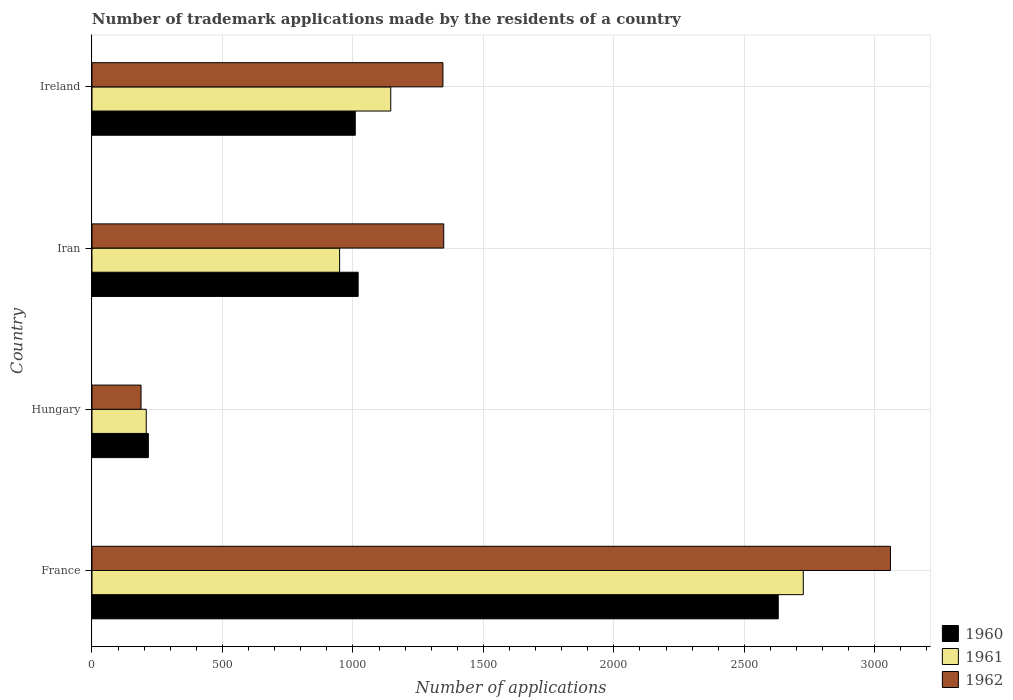Are the number of bars on each tick of the Y-axis equal?
Your answer should be very brief. Yes. How many bars are there on the 4th tick from the top?
Your response must be concise. 3. What is the label of the 3rd group of bars from the top?
Your answer should be compact. Hungary. What is the number of trademark applications made by the residents in 1962 in Iran?
Your answer should be very brief. 1348. Across all countries, what is the maximum number of trademark applications made by the residents in 1960?
Provide a short and direct response. 2630. Across all countries, what is the minimum number of trademark applications made by the residents in 1961?
Your response must be concise. 208. In which country was the number of trademark applications made by the residents in 1961 minimum?
Your response must be concise. Hungary. What is the total number of trademark applications made by the residents in 1961 in the graph?
Provide a short and direct response. 5028. What is the difference between the number of trademark applications made by the residents in 1961 in France and that in Hungary?
Offer a terse response. 2518. What is the difference between the number of trademark applications made by the residents in 1960 in Ireland and the number of trademark applications made by the residents in 1961 in France?
Provide a short and direct response. -1717. What is the average number of trademark applications made by the residents in 1962 per country?
Provide a short and direct response. 1485.25. What is the difference between the number of trademark applications made by the residents in 1960 and number of trademark applications made by the residents in 1961 in Ireland?
Your answer should be compact. -136. What is the ratio of the number of trademark applications made by the residents in 1960 in France to that in Iran?
Your answer should be compact. 2.58. Is the difference between the number of trademark applications made by the residents in 1960 in France and Hungary greater than the difference between the number of trademark applications made by the residents in 1961 in France and Hungary?
Keep it short and to the point. No. What is the difference between the highest and the second highest number of trademark applications made by the residents in 1960?
Keep it short and to the point. 1610. What is the difference between the highest and the lowest number of trademark applications made by the residents in 1962?
Give a very brief answer. 2872. Is the sum of the number of trademark applications made by the residents in 1962 in Iran and Ireland greater than the maximum number of trademark applications made by the residents in 1960 across all countries?
Your answer should be compact. Yes. Is it the case that in every country, the sum of the number of trademark applications made by the residents in 1961 and number of trademark applications made by the residents in 1962 is greater than the number of trademark applications made by the residents in 1960?
Offer a very short reply. Yes. Are all the bars in the graph horizontal?
Provide a succinct answer. Yes. What is the difference between two consecutive major ticks on the X-axis?
Provide a short and direct response. 500. Are the values on the major ticks of X-axis written in scientific E-notation?
Ensure brevity in your answer.  No. Does the graph contain any zero values?
Offer a terse response. No. Where does the legend appear in the graph?
Your answer should be very brief. Bottom right. How many legend labels are there?
Make the answer very short. 3. What is the title of the graph?
Make the answer very short. Number of trademark applications made by the residents of a country. What is the label or title of the X-axis?
Your response must be concise. Number of applications. What is the Number of applications of 1960 in France?
Your answer should be very brief. 2630. What is the Number of applications in 1961 in France?
Offer a very short reply. 2726. What is the Number of applications in 1962 in France?
Ensure brevity in your answer.  3060. What is the Number of applications in 1960 in Hungary?
Give a very brief answer. 216. What is the Number of applications of 1961 in Hungary?
Give a very brief answer. 208. What is the Number of applications of 1962 in Hungary?
Give a very brief answer. 188. What is the Number of applications in 1960 in Iran?
Provide a succinct answer. 1020. What is the Number of applications of 1961 in Iran?
Your response must be concise. 949. What is the Number of applications of 1962 in Iran?
Provide a short and direct response. 1348. What is the Number of applications of 1960 in Ireland?
Give a very brief answer. 1009. What is the Number of applications in 1961 in Ireland?
Offer a very short reply. 1145. What is the Number of applications of 1962 in Ireland?
Keep it short and to the point. 1345. Across all countries, what is the maximum Number of applications in 1960?
Ensure brevity in your answer.  2630. Across all countries, what is the maximum Number of applications in 1961?
Your response must be concise. 2726. Across all countries, what is the maximum Number of applications in 1962?
Keep it short and to the point. 3060. Across all countries, what is the minimum Number of applications of 1960?
Provide a succinct answer. 216. Across all countries, what is the minimum Number of applications of 1961?
Your answer should be compact. 208. Across all countries, what is the minimum Number of applications in 1962?
Keep it short and to the point. 188. What is the total Number of applications in 1960 in the graph?
Provide a short and direct response. 4875. What is the total Number of applications in 1961 in the graph?
Your answer should be compact. 5028. What is the total Number of applications of 1962 in the graph?
Your answer should be very brief. 5941. What is the difference between the Number of applications of 1960 in France and that in Hungary?
Give a very brief answer. 2414. What is the difference between the Number of applications in 1961 in France and that in Hungary?
Your response must be concise. 2518. What is the difference between the Number of applications in 1962 in France and that in Hungary?
Ensure brevity in your answer.  2872. What is the difference between the Number of applications of 1960 in France and that in Iran?
Your response must be concise. 1610. What is the difference between the Number of applications of 1961 in France and that in Iran?
Your response must be concise. 1777. What is the difference between the Number of applications of 1962 in France and that in Iran?
Give a very brief answer. 1712. What is the difference between the Number of applications of 1960 in France and that in Ireland?
Provide a short and direct response. 1621. What is the difference between the Number of applications in 1961 in France and that in Ireland?
Give a very brief answer. 1581. What is the difference between the Number of applications of 1962 in France and that in Ireland?
Your answer should be compact. 1715. What is the difference between the Number of applications in 1960 in Hungary and that in Iran?
Keep it short and to the point. -804. What is the difference between the Number of applications in 1961 in Hungary and that in Iran?
Your response must be concise. -741. What is the difference between the Number of applications of 1962 in Hungary and that in Iran?
Give a very brief answer. -1160. What is the difference between the Number of applications of 1960 in Hungary and that in Ireland?
Offer a very short reply. -793. What is the difference between the Number of applications of 1961 in Hungary and that in Ireland?
Your response must be concise. -937. What is the difference between the Number of applications in 1962 in Hungary and that in Ireland?
Give a very brief answer. -1157. What is the difference between the Number of applications of 1961 in Iran and that in Ireland?
Your answer should be compact. -196. What is the difference between the Number of applications in 1960 in France and the Number of applications in 1961 in Hungary?
Your answer should be compact. 2422. What is the difference between the Number of applications of 1960 in France and the Number of applications of 1962 in Hungary?
Give a very brief answer. 2442. What is the difference between the Number of applications of 1961 in France and the Number of applications of 1962 in Hungary?
Give a very brief answer. 2538. What is the difference between the Number of applications in 1960 in France and the Number of applications in 1961 in Iran?
Your answer should be compact. 1681. What is the difference between the Number of applications of 1960 in France and the Number of applications of 1962 in Iran?
Provide a short and direct response. 1282. What is the difference between the Number of applications of 1961 in France and the Number of applications of 1962 in Iran?
Make the answer very short. 1378. What is the difference between the Number of applications of 1960 in France and the Number of applications of 1961 in Ireland?
Offer a very short reply. 1485. What is the difference between the Number of applications in 1960 in France and the Number of applications in 1962 in Ireland?
Offer a very short reply. 1285. What is the difference between the Number of applications in 1961 in France and the Number of applications in 1962 in Ireland?
Ensure brevity in your answer.  1381. What is the difference between the Number of applications of 1960 in Hungary and the Number of applications of 1961 in Iran?
Keep it short and to the point. -733. What is the difference between the Number of applications of 1960 in Hungary and the Number of applications of 1962 in Iran?
Provide a succinct answer. -1132. What is the difference between the Number of applications in 1961 in Hungary and the Number of applications in 1962 in Iran?
Your answer should be compact. -1140. What is the difference between the Number of applications in 1960 in Hungary and the Number of applications in 1961 in Ireland?
Make the answer very short. -929. What is the difference between the Number of applications of 1960 in Hungary and the Number of applications of 1962 in Ireland?
Give a very brief answer. -1129. What is the difference between the Number of applications in 1961 in Hungary and the Number of applications in 1962 in Ireland?
Make the answer very short. -1137. What is the difference between the Number of applications of 1960 in Iran and the Number of applications of 1961 in Ireland?
Give a very brief answer. -125. What is the difference between the Number of applications in 1960 in Iran and the Number of applications in 1962 in Ireland?
Your answer should be compact. -325. What is the difference between the Number of applications in 1961 in Iran and the Number of applications in 1962 in Ireland?
Offer a terse response. -396. What is the average Number of applications of 1960 per country?
Your answer should be compact. 1218.75. What is the average Number of applications in 1961 per country?
Provide a succinct answer. 1257. What is the average Number of applications in 1962 per country?
Keep it short and to the point. 1485.25. What is the difference between the Number of applications of 1960 and Number of applications of 1961 in France?
Offer a terse response. -96. What is the difference between the Number of applications of 1960 and Number of applications of 1962 in France?
Offer a very short reply. -430. What is the difference between the Number of applications in 1961 and Number of applications in 1962 in France?
Make the answer very short. -334. What is the difference between the Number of applications of 1960 and Number of applications of 1961 in Hungary?
Your answer should be very brief. 8. What is the difference between the Number of applications in 1960 and Number of applications in 1962 in Hungary?
Your response must be concise. 28. What is the difference between the Number of applications of 1961 and Number of applications of 1962 in Hungary?
Ensure brevity in your answer.  20. What is the difference between the Number of applications in 1960 and Number of applications in 1961 in Iran?
Your response must be concise. 71. What is the difference between the Number of applications of 1960 and Number of applications of 1962 in Iran?
Keep it short and to the point. -328. What is the difference between the Number of applications of 1961 and Number of applications of 1962 in Iran?
Offer a very short reply. -399. What is the difference between the Number of applications in 1960 and Number of applications in 1961 in Ireland?
Ensure brevity in your answer.  -136. What is the difference between the Number of applications in 1960 and Number of applications in 1962 in Ireland?
Give a very brief answer. -336. What is the difference between the Number of applications of 1961 and Number of applications of 1962 in Ireland?
Your response must be concise. -200. What is the ratio of the Number of applications in 1960 in France to that in Hungary?
Provide a succinct answer. 12.18. What is the ratio of the Number of applications of 1961 in France to that in Hungary?
Keep it short and to the point. 13.11. What is the ratio of the Number of applications of 1962 in France to that in Hungary?
Your answer should be compact. 16.28. What is the ratio of the Number of applications in 1960 in France to that in Iran?
Provide a short and direct response. 2.58. What is the ratio of the Number of applications in 1961 in France to that in Iran?
Keep it short and to the point. 2.87. What is the ratio of the Number of applications in 1962 in France to that in Iran?
Provide a short and direct response. 2.27. What is the ratio of the Number of applications of 1960 in France to that in Ireland?
Your answer should be compact. 2.61. What is the ratio of the Number of applications in 1961 in France to that in Ireland?
Your answer should be compact. 2.38. What is the ratio of the Number of applications of 1962 in France to that in Ireland?
Your answer should be compact. 2.28. What is the ratio of the Number of applications in 1960 in Hungary to that in Iran?
Your answer should be very brief. 0.21. What is the ratio of the Number of applications in 1961 in Hungary to that in Iran?
Keep it short and to the point. 0.22. What is the ratio of the Number of applications in 1962 in Hungary to that in Iran?
Offer a terse response. 0.14. What is the ratio of the Number of applications of 1960 in Hungary to that in Ireland?
Your response must be concise. 0.21. What is the ratio of the Number of applications in 1961 in Hungary to that in Ireland?
Your answer should be compact. 0.18. What is the ratio of the Number of applications of 1962 in Hungary to that in Ireland?
Keep it short and to the point. 0.14. What is the ratio of the Number of applications of 1960 in Iran to that in Ireland?
Your answer should be very brief. 1.01. What is the ratio of the Number of applications of 1961 in Iran to that in Ireland?
Provide a succinct answer. 0.83. What is the ratio of the Number of applications in 1962 in Iran to that in Ireland?
Your response must be concise. 1. What is the difference between the highest and the second highest Number of applications in 1960?
Ensure brevity in your answer.  1610. What is the difference between the highest and the second highest Number of applications of 1961?
Offer a very short reply. 1581. What is the difference between the highest and the second highest Number of applications of 1962?
Keep it short and to the point. 1712. What is the difference between the highest and the lowest Number of applications in 1960?
Your answer should be very brief. 2414. What is the difference between the highest and the lowest Number of applications of 1961?
Make the answer very short. 2518. What is the difference between the highest and the lowest Number of applications in 1962?
Offer a very short reply. 2872. 